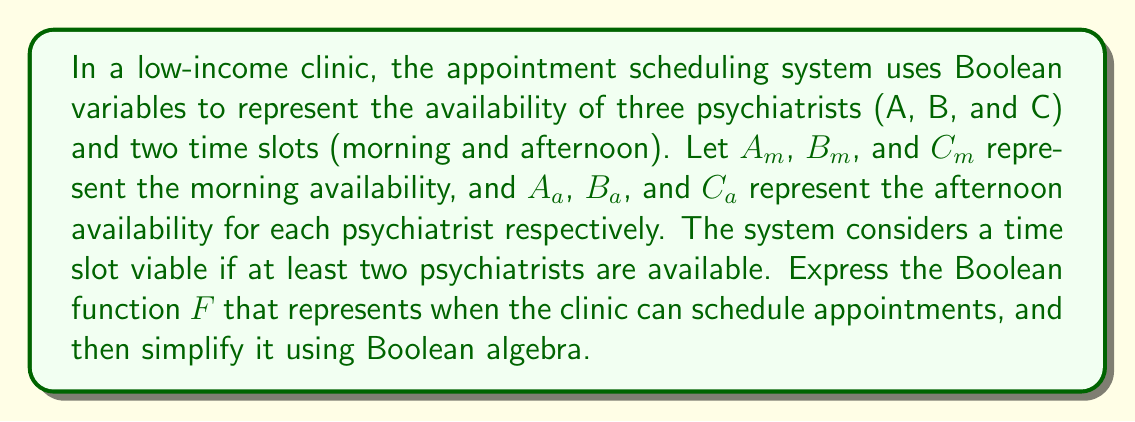Help me with this question. 1. First, let's express the function $F$ in terms of the given variables:

   $F = (A_m \cdot B_m + A_m \cdot C_m + B_m \cdot C_m) + (A_a \cdot B_a + A_a \cdot C_a + B_a \cdot C_a)$

2. Let's focus on simplifying the morning and afternoon terms separately:
   
   Morning term: $M = A_m \cdot B_m + A_m \cdot C_m + B_m \cdot C_m$
   Afternoon term: $N = A_a \cdot B_a + A_a \cdot C_a + B_a \cdot C_a$

3. We can apply the distributive law to factor out common terms:

   $M = A_m \cdot (B_m + C_m) + B_m \cdot C_m$
   $N = A_a \cdot (B_a + C_a) + B_a \cdot C_a$

4. Now, we can apply the absorption law $(X + Y \cdot Z = X + Z)$ to both terms:

   $M = A_m + B_m \cdot C_m$
   $N = A_a + B_a \cdot C_a$

5. The final simplified function is:

   $F = (A_m + B_m \cdot C_m) + (A_a + B_a \cdot C_a)$

This simplified function represents when the clinic can schedule appointments, either in the morning or afternoon, based on psychiatrist availability.
Answer: $F = (A_m + B_m \cdot C_m) + (A_a + B_a \cdot C_a)$ 